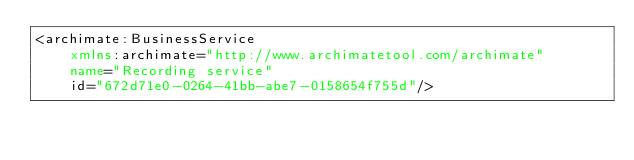Convert code to text. <code><loc_0><loc_0><loc_500><loc_500><_XML_><archimate:BusinessService
    xmlns:archimate="http://www.archimatetool.com/archimate"
    name="Recording service"
    id="672d71e0-0264-41bb-abe7-0158654f755d"/>
</code> 